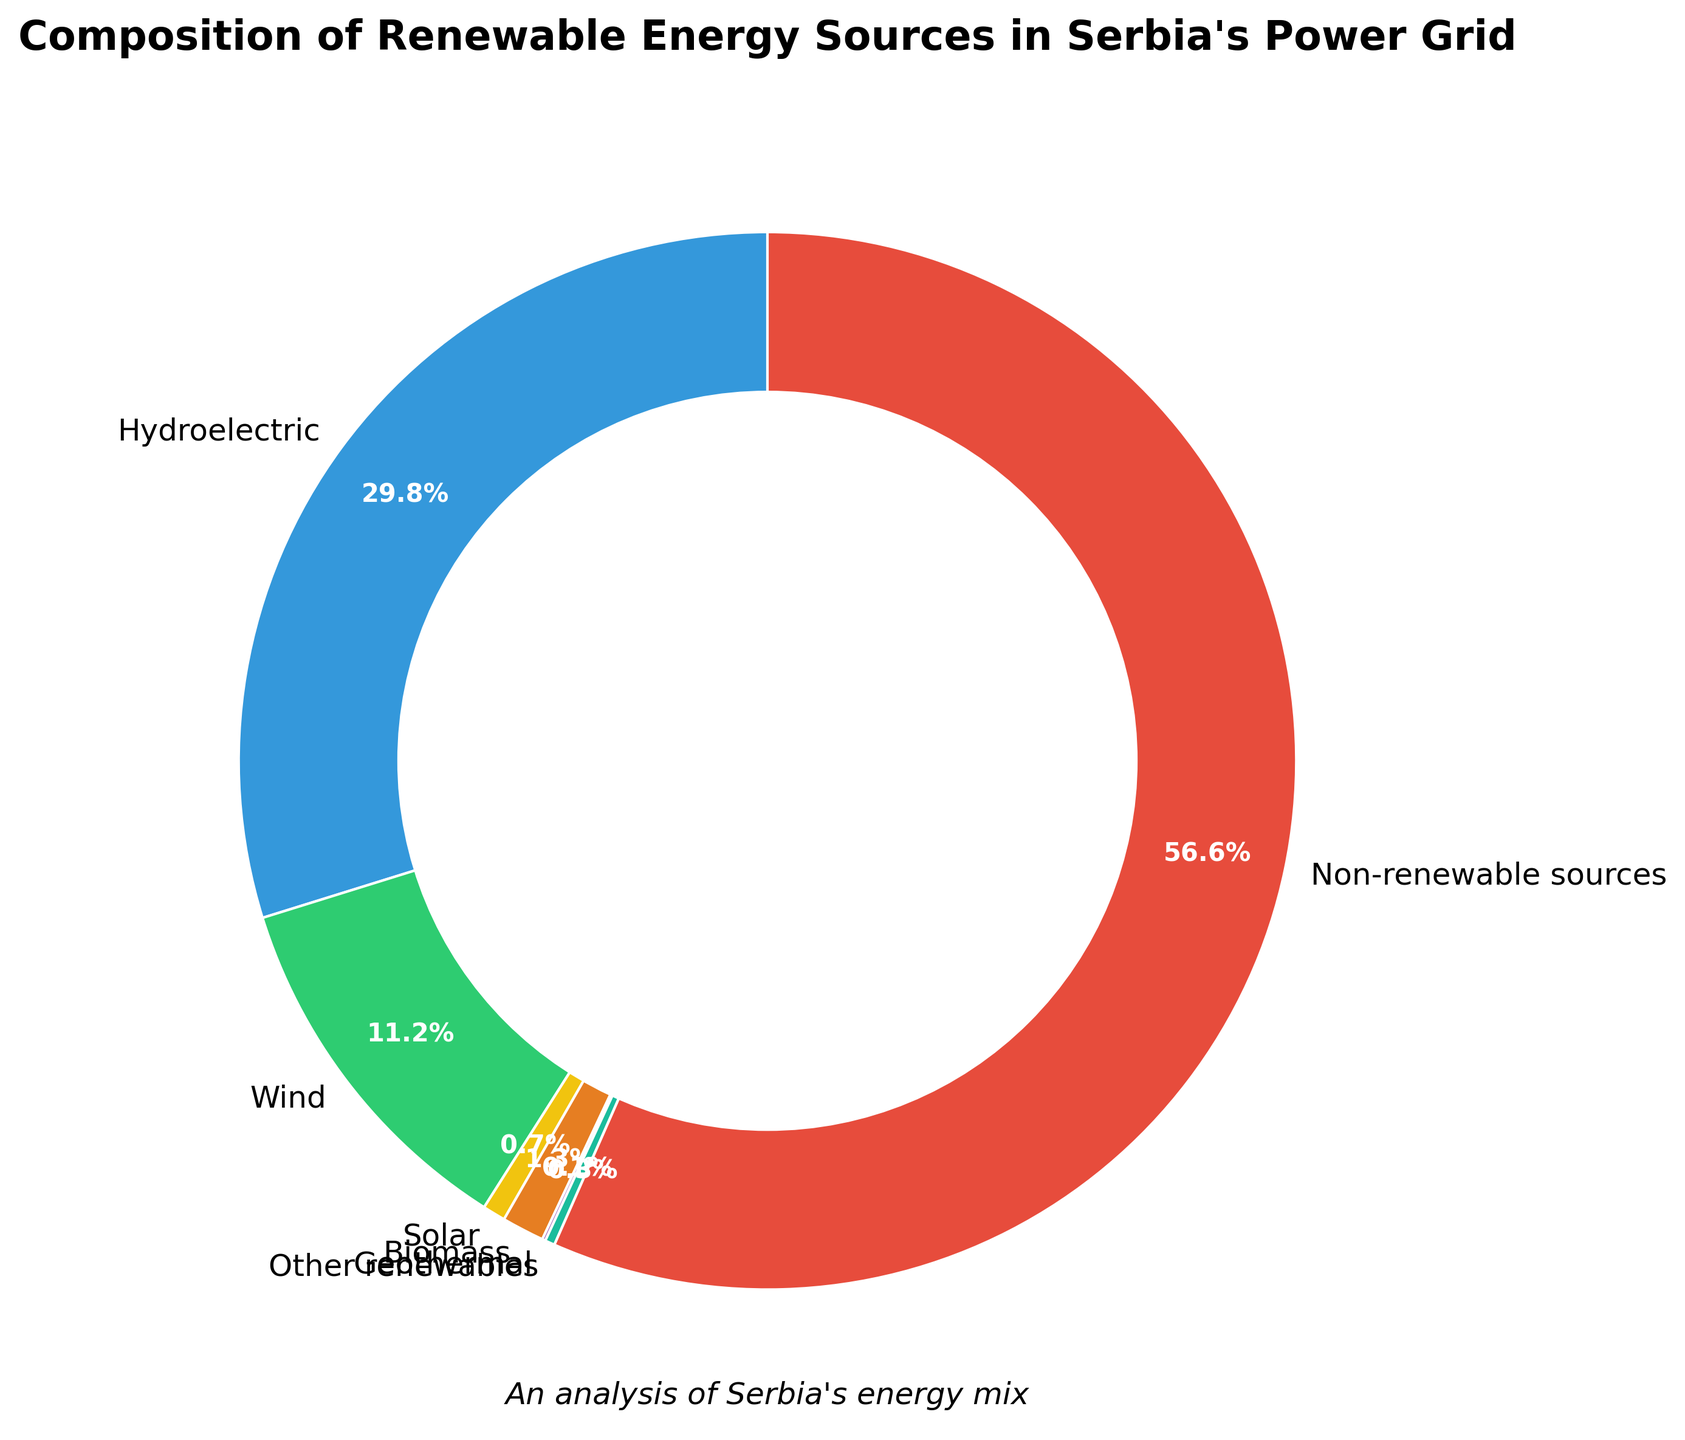What is the largest renewable energy source in Serbia's power grid? The pie chart shows the various renewable energy sources and their respective percentages. The slice labeled "Hydroelectric" occupies the largest portion of the renewable sources section, indicating it is the largest.
Answer: Hydroelectric What percentage of Serbia's power grid comes from non-renewable sources? By referring to the section labeled "Non-renewable sources" in the pie chart, you can see the percentage value.
Answer: 56.6% How much larger is the percentage of hydroelectric power compared to wind power? Look at the slices labeled "Hydroelectric" (29.8%) and "Wind" (11.2%). Subtract the wind percentage from the hydroelectric percentage. 29.8% - 11.2% = 18.6%
Answer: 18.6% What is the combined percentage for solar and biomass energy sources? Find the slices labeled "Solar" (0.7%) and "Biomass" (1.3%). Add these values together: 0.7% + 1.3% = 2.0%
Answer: 2.0% Between geothermal and other renewables, which source has a smaller contribution and by how much? The slices corresponding to "Geothermal" (0.1%) and "Other renewables" (0.3%) show their contributions. Subtract geothermal from other renewables: 0.3% - 0.1% = 0.2%
Answer: Geothermal, by 0.2% What is the total percentage of renewable energy sources in Serbia's power grid? Sum up the percentages of all renewable energy sources: Hydroelectric (29.8%), Wind (11.2%), Solar (0.7%), Biomass (1.3%), Geothermal (0.1%), and Other renewables (0.3%). 29.8% + 11.2% + 0.7% + 1.3% + 0.1% + 0.3% = 43.4%
Answer: 43.4% Which renewable energy source is represented with the green color? Refer to the color attributed to the slice labeled "Wind" on the pie chart, which is green.
Answer: Wind 